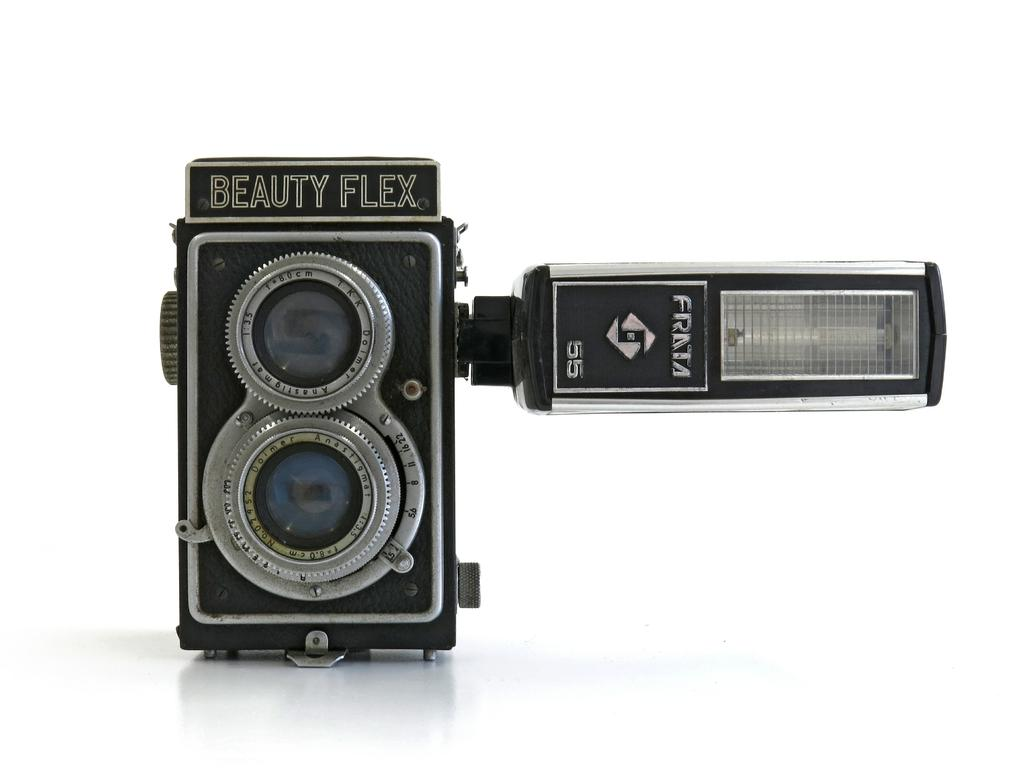<image>
Create a compact narrative representing the image presented. a camera that has the brand name 'beauty flex' on it 